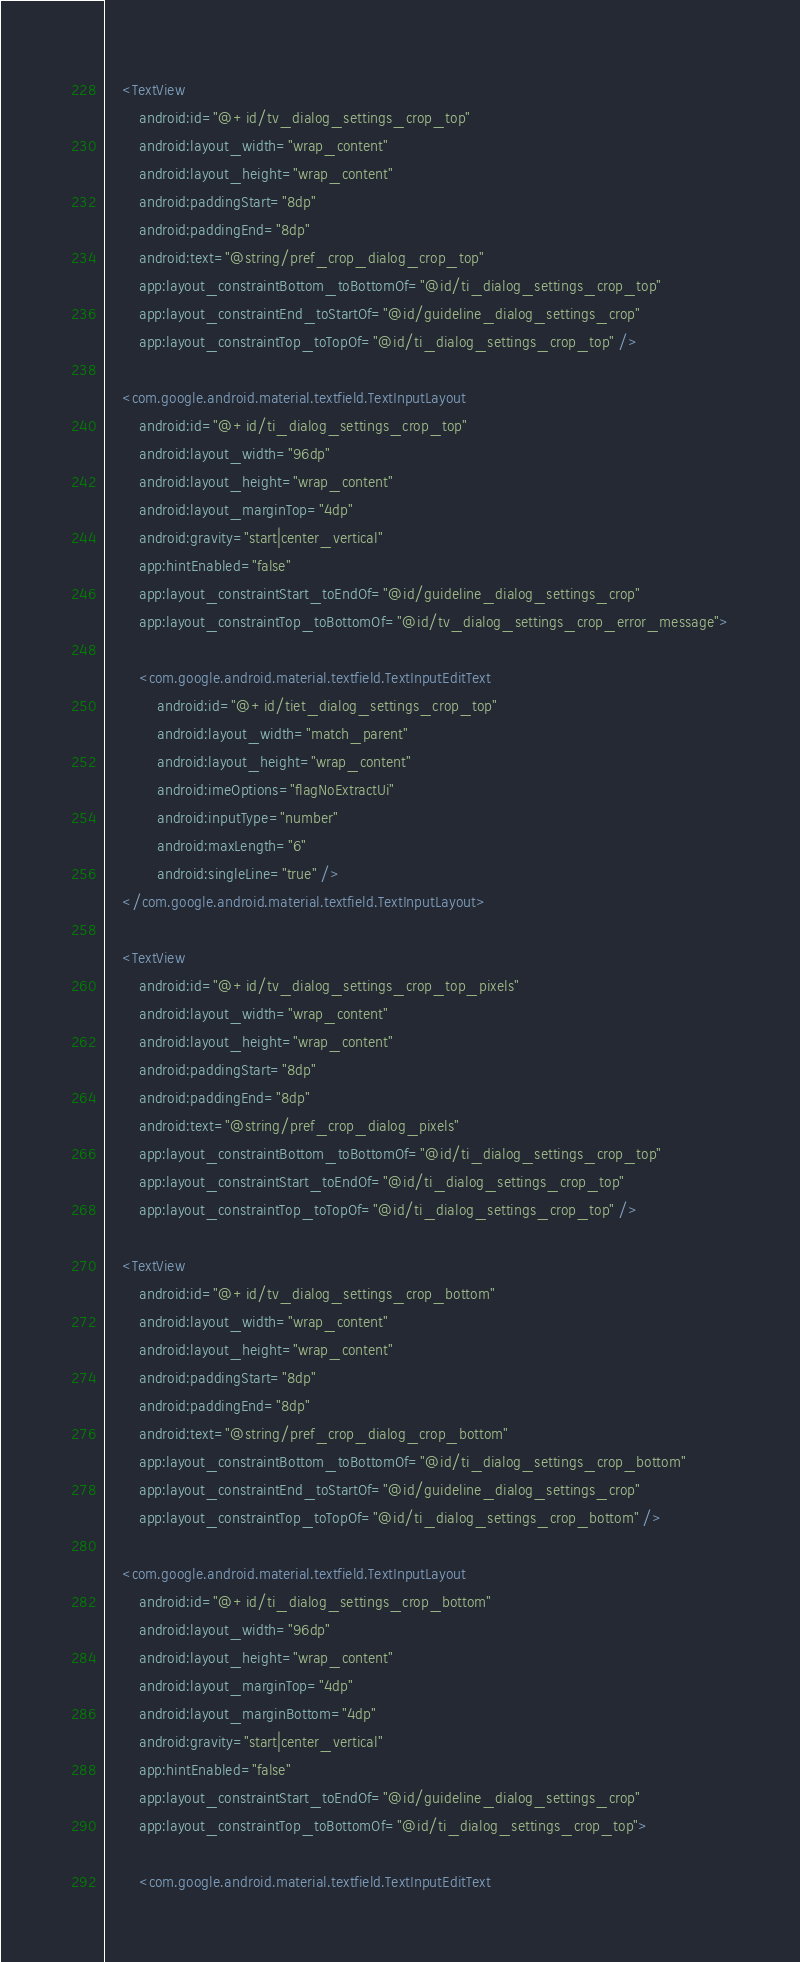<code> <loc_0><loc_0><loc_500><loc_500><_XML_>
    <TextView
        android:id="@+id/tv_dialog_settings_crop_top"
        android:layout_width="wrap_content"
        android:layout_height="wrap_content"
        android:paddingStart="8dp"
        android:paddingEnd="8dp"
        android:text="@string/pref_crop_dialog_crop_top"
        app:layout_constraintBottom_toBottomOf="@id/ti_dialog_settings_crop_top"
        app:layout_constraintEnd_toStartOf="@id/guideline_dialog_settings_crop"
        app:layout_constraintTop_toTopOf="@id/ti_dialog_settings_crop_top" />

    <com.google.android.material.textfield.TextInputLayout
        android:id="@+id/ti_dialog_settings_crop_top"
        android:layout_width="96dp"
        android:layout_height="wrap_content"
        android:layout_marginTop="4dp"
        android:gravity="start|center_vertical"
        app:hintEnabled="false"
        app:layout_constraintStart_toEndOf="@id/guideline_dialog_settings_crop"
        app:layout_constraintTop_toBottomOf="@id/tv_dialog_settings_crop_error_message">

        <com.google.android.material.textfield.TextInputEditText
            android:id="@+id/tiet_dialog_settings_crop_top"
            android:layout_width="match_parent"
            android:layout_height="wrap_content"
            android:imeOptions="flagNoExtractUi"
            android:inputType="number"
            android:maxLength="6"
            android:singleLine="true" />
    </com.google.android.material.textfield.TextInputLayout>

    <TextView
        android:id="@+id/tv_dialog_settings_crop_top_pixels"
        android:layout_width="wrap_content"
        android:layout_height="wrap_content"
        android:paddingStart="8dp"
        android:paddingEnd="8dp"
        android:text="@string/pref_crop_dialog_pixels"
        app:layout_constraintBottom_toBottomOf="@id/ti_dialog_settings_crop_top"
        app:layout_constraintStart_toEndOf="@id/ti_dialog_settings_crop_top"
        app:layout_constraintTop_toTopOf="@id/ti_dialog_settings_crop_top" />

    <TextView
        android:id="@+id/tv_dialog_settings_crop_bottom"
        android:layout_width="wrap_content"
        android:layout_height="wrap_content"
        android:paddingStart="8dp"
        android:paddingEnd="8dp"
        android:text="@string/pref_crop_dialog_crop_bottom"
        app:layout_constraintBottom_toBottomOf="@id/ti_dialog_settings_crop_bottom"
        app:layout_constraintEnd_toStartOf="@id/guideline_dialog_settings_crop"
        app:layout_constraintTop_toTopOf="@id/ti_dialog_settings_crop_bottom" />

    <com.google.android.material.textfield.TextInputLayout
        android:id="@+id/ti_dialog_settings_crop_bottom"
        android:layout_width="96dp"
        android:layout_height="wrap_content"
        android:layout_marginTop="4dp"
        android:layout_marginBottom="4dp"
        android:gravity="start|center_vertical"
        app:hintEnabled="false"
        app:layout_constraintStart_toEndOf="@id/guideline_dialog_settings_crop"
        app:layout_constraintTop_toBottomOf="@id/ti_dialog_settings_crop_top">

        <com.google.android.material.textfield.TextInputEditText</code> 